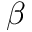<formula> <loc_0><loc_0><loc_500><loc_500>\beta</formula> 